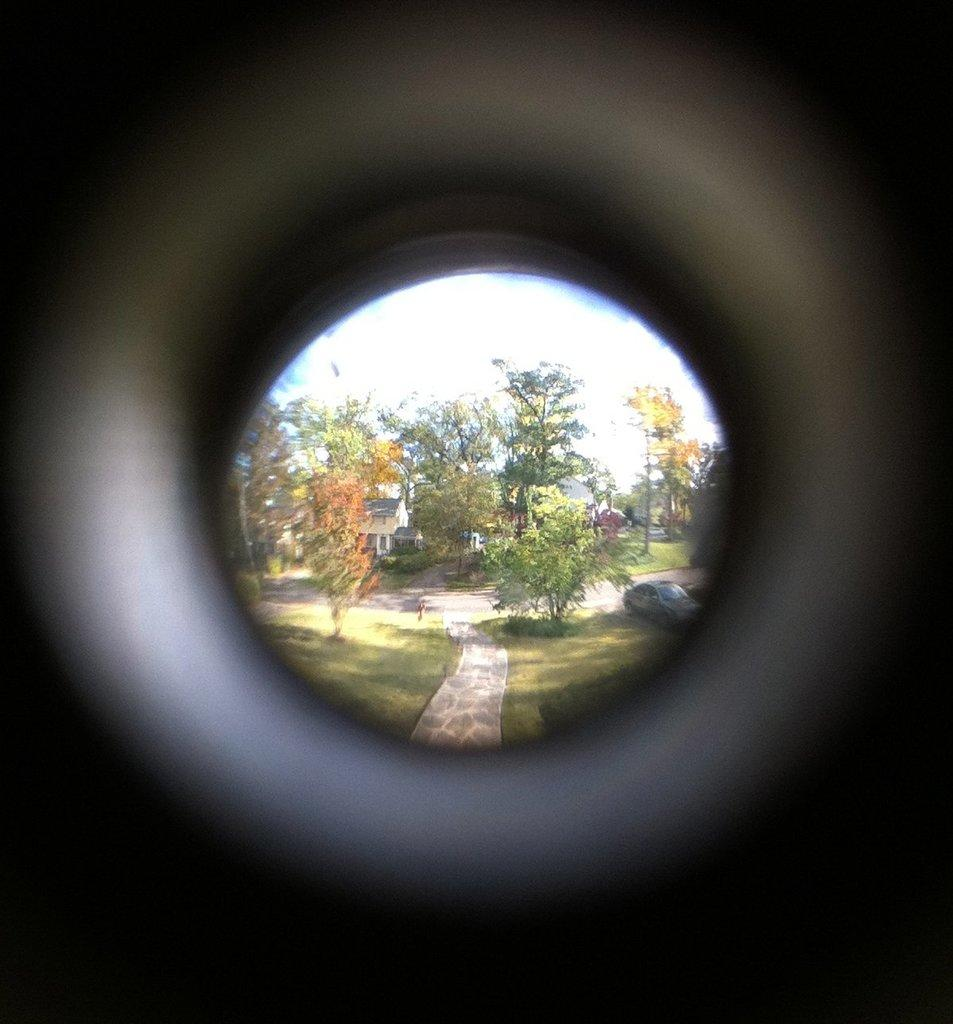What is located in the center of the image? There are trees in the center of the image. What can be seen at the bottom of the image? There is a walkway at the bottom of the image. What is on the right side of the image? There is a car on the right side of the image. What is visible in the background of the image? The sky is visible in the background of the image. Can you tell me how many eggs are on the walkway in the image? There are no eggs present on the walkway in the image. What type of chin can be seen on the car in the image? There is no chin present on the car in the image; it is a vehicle, not a living being. 